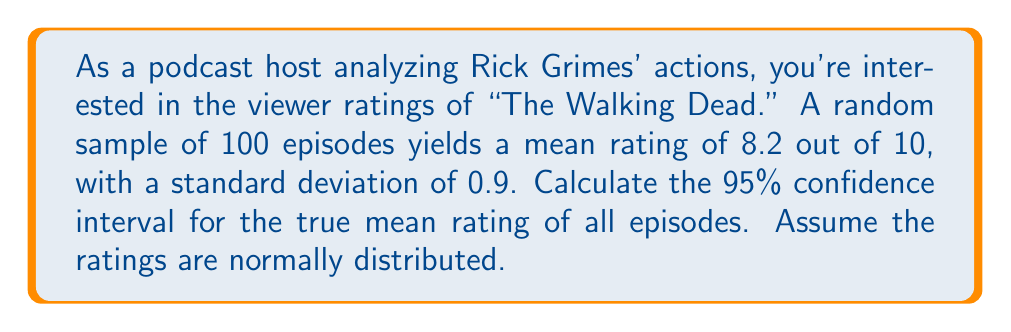Show me your answer to this math problem. To calculate the confidence interval, we'll follow these steps:

1) The formula for a confidence interval is:

   $$\bar{x} \pm z_{\alpha/2} \cdot \frac{\sigma}{\sqrt{n}}$$

   Where:
   $\bar{x}$ is the sample mean
   $z_{\alpha/2}$ is the critical value (for 95% CI, this is 1.96)
   $\sigma$ is the population standard deviation
   $n$ is the sample size

2) We have:
   $\bar{x} = 8.2$
   $z_{\alpha/2} = 1.96$ (for 95% CI)
   $\sigma = 0.9$ (we'll use the sample standard deviation as an estimate)
   $n = 100$

3) Plugging these values into the formula:

   $$8.2 \pm 1.96 \cdot \frac{0.9}{\sqrt{100}}$$

4) Simplify:
   $$8.2 \pm 1.96 \cdot \frac{0.9}{10}$$
   $$8.2 \pm 1.96 \cdot 0.09$$
   $$8.2 \pm 0.1764$$

5) Calculate the interval:
   Lower bound: $8.2 - 0.1764 = 8.0236$
   Upper bound: $8.2 + 0.1764 = 8.3764$

6) Round to two decimal places:
   (8.02, 8.38)
Answer: (8.02, 8.38) 